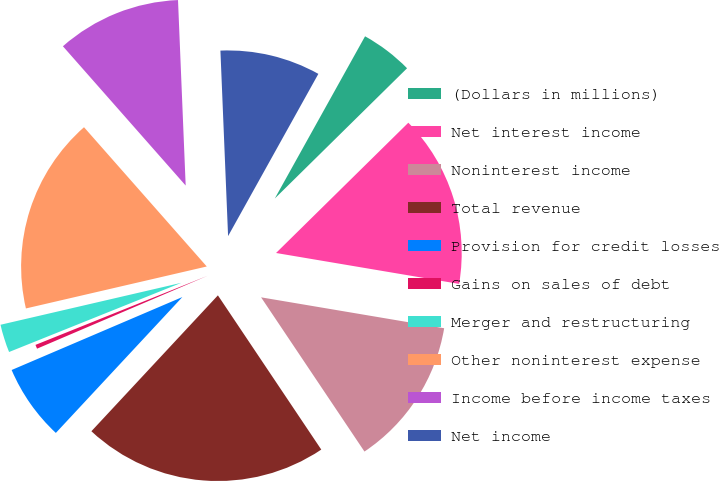<chart> <loc_0><loc_0><loc_500><loc_500><pie_chart><fcel>(Dollars in millions)<fcel>Net interest income<fcel>Noninterest income<fcel>Total revenue<fcel>Provision for credit losses<fcel>Gains on sales of debt<fcel>Merger and restructuring<fcel>Other noninterest expense<fcel>Income before income taxes<fcel>Net income<nl><fcel>4.54%<fcel>15.04%<fcel>12.94%<fcel>21.33%<fcel>6.64%<fcel>0.35%<fcel>2.45%<fcel>17.13%<fcel>10.84%<fcel>8.74%<nl></chart> 